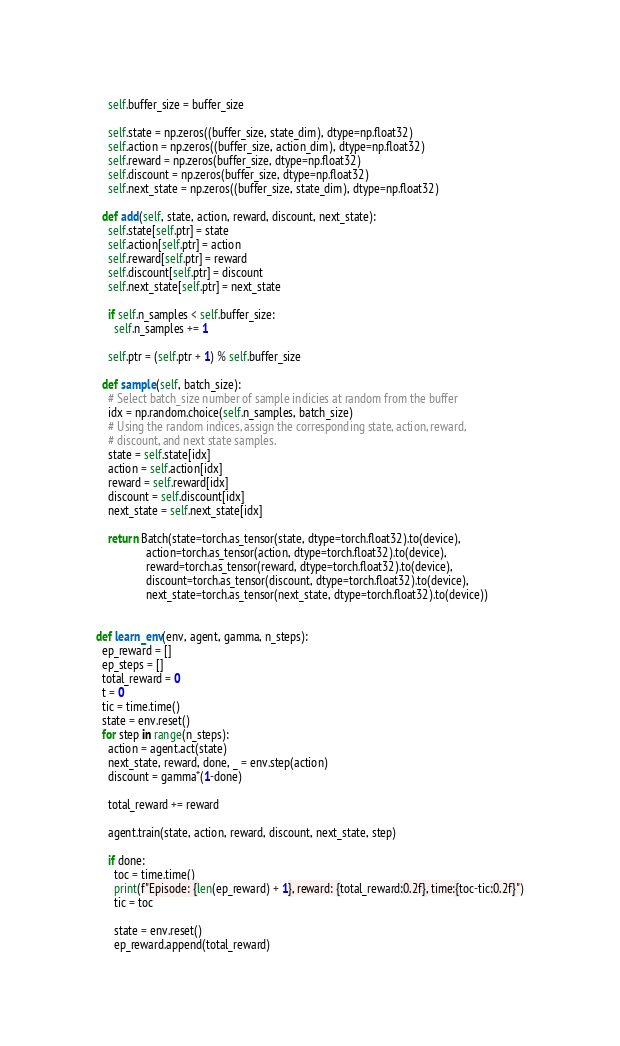<code> <loc_0><loc_0><loc_500><loc_500><_Python_>    self.buffer_size = buffer_size
    
    self.state = np.zeros((buffer_size, state_dim), dtype=np.float32)        
    self.action = np.zeros((buffer_size, action_dim), dtype=np.float32)
    self.reward = np.zeros(buffer_size, dtype=np.float32)
    self.discount = np.zeros(buffer_size, dtype=np.float32)
    self.next_state = np.zeros((buffer_size, state_dim), dtype=np.float32)

  def add(self, state, action, reward, discount, next_state):
    self.state[self.ptr] = state
    self.action[self.ptr] = action
    self.reward[self.ptr] = reward
    self.discount[self.ptr] = discount
    self.next_state[self.ptr] = next_state

    if self.n_samples < self.buffer_size:
      self.n_samples += 1

    self.ptr = (self.ptr + 1) % self.buffer_size

  def sample(self, batch_size):
    # Select batch_size number of sample indicies at random from the buffer
    idx = np.random.choice(self.n_samples, batch_size)    
    # Using the random indices, assign the corresponding state, action, reward,
    # discount, and next state samples.
    state = self.state[idx]
    action = self.action[idx]
    reward = self.reward[idx]
    discount = self.discount[idx]
    next_state = self.next_state[idx]
      
    return Batch(state=torch.as_tensor(state, dtype=torch.float32).to(device),
                 action=torch.as_tensor(action, dtype=torch.float32).to(device),
                 reward=torch.as_tensor(reward, dtype=torch.float32).to(device),
                 discount=torch.as_tensor(discount, dtype=torch.float32).to(device),
                 next_state=torch.as_tensor(next_state, dtype=torch.float32).to(device))


def learn_env(env, agent, gamma, n_steps):
  ep_reward = []
  ep_steps = []
  total_reward = 0
  t = 0
  tic = time.time()
  state = env.reset()
  for step in range(n_steps):
    action = agent.act(state)
    next_state, reward, done, _ = env.step(action)    
    discount = gamma*(1-done)
    
    total_reward += reward  
  
    agent.train(state, action, reward, discount, next_state, step)

    if done:
      toc = time.time()      
      print(f"Episode: {len(ep_reward) + 1}, reward: {total_reward:0.2f}, time:{toc-tic:0.2f}")
      tic = toc

      state = env.reset()      
      ep_reward.append(total_reward)</code> 